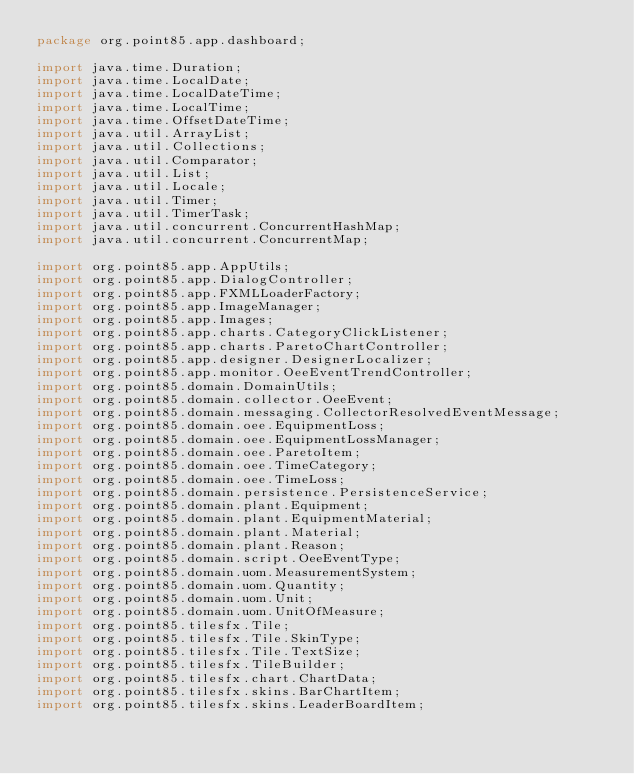Convert code to text. <code><loc_0><loc_0><loc_500><loc_500><_Java_>package org.point85.app.dashboard;

import java.time.Duration;
import java.time.LocalDate;
import java.time.LocalDateTime;
import java.time.LocalTime;
import java.time.OffsetDateTime;
import java.util.ArrayList;
import java.util.Collections;
import java.util.Comparator;
import java.util.List;
import java.util.Locale;
import java.util.Timer;
import java.util.TimerTask;
import java.util.concurrent.ConcurrentHashMap;
import java.util.concurrent.ConcurrentMap;

import org.point85.app.AppUtils;
import org.point85.app.DialogController;
import org.point85.app.FXMLLoaderFactory;
import org.point85.app.ImageManager;
import org.point85.app.Images;
import org.point85.app.charts.CategoryClickListener;
import org.point85.app.charts.ParetoChartController;
import org.point85.app.designer.DesignerLocalizer;
import org.point85.app.monitor.OeeEventTrendController;
import org.point85.domain.DomainUtils;
import org.point85.domain.collector.OeeEvent;
import org.point85.domain.messaging.CollectorResolvedEventMessage;
import org.point85.domain.oee.EquipmentLoss;
import org.point85.domain.oee.EquipmentLossManager;
import org.point85.domain.oee.ParetoItem;
import org.point85.domain.oee.TimeCategory;
import org.point85.domain.oee.TimeLoss;
import org.point85.domain.persistence.PersistenceService;
import org.point85.domain.plant.Equipment;
import org.point85.domain.plant.EquipmentMaterial;
import org.point85.domain.plant.Material;
import org.point85.domain.plant.Reason;
import org.point85.domain.script.OeeEventType;
import org.point85.domain.uom.MeasurementSystem;
import org.point85.domain.uom.Quantity;
import org.point85.domain.uom.Unit;
import org.point85.domain.uom.UnitOfMeasure;
import org.point85.tilesfx.Tile;
import org.point85.tilesfx.Tile.SkinType;
import org.point85.tilesfx.Tile.TextSize;
import org.point85.tilesfx.TileBuilder;
import org.point85.tilesfx.chart.ChartData;
import org.point85.tilesfx.skins.BarChartItem;
import org.point85.tilesfx.skins.LeaderBoardItem;</code> 